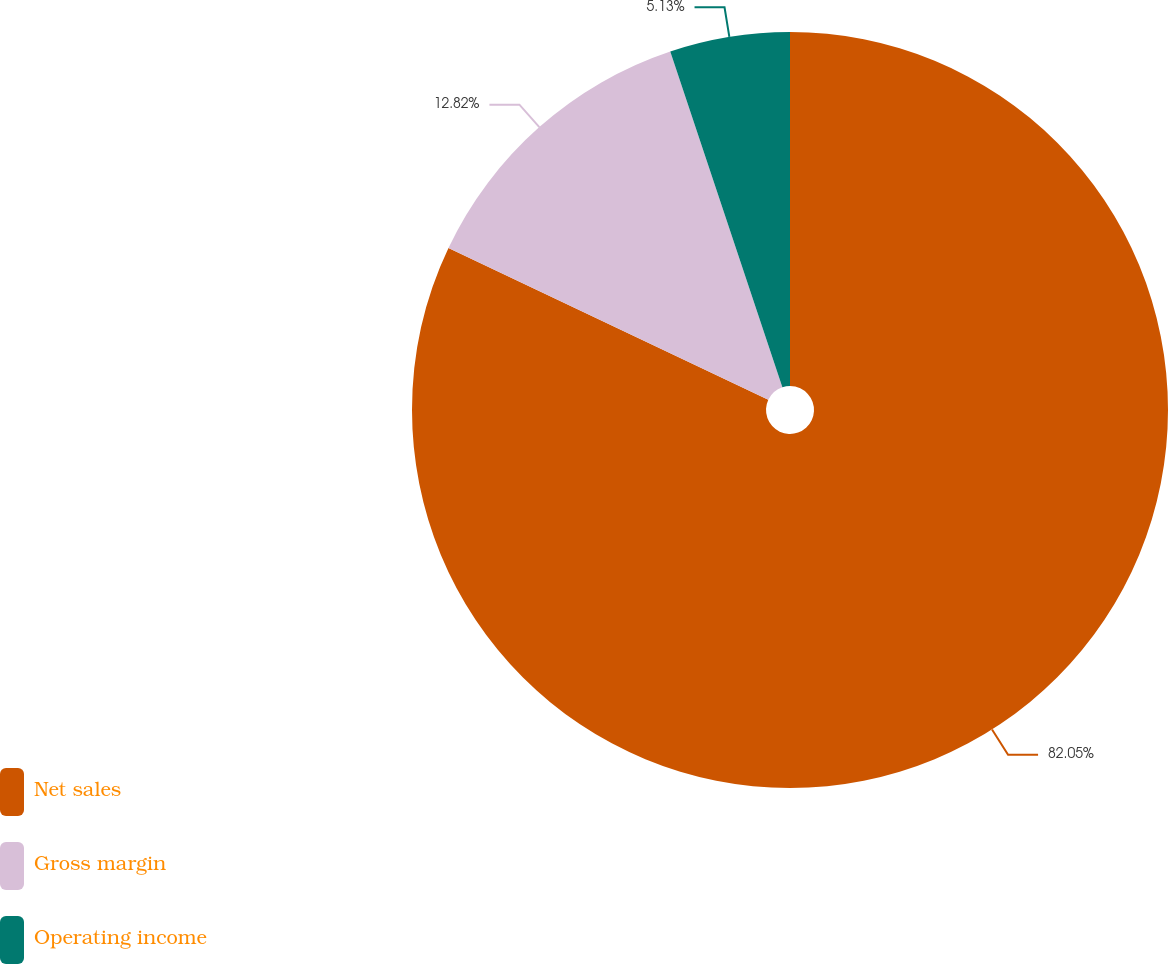Convert chart to OTSL. <chart><loc_0><loc_0><loc_500><loc_500><pie_chart><fcel>Net sales<fcel>Gross margin<fcel>Operating income<nl><fcel>82.05%<fcel>12.82%<fcel>5.13%<nl></chart> 